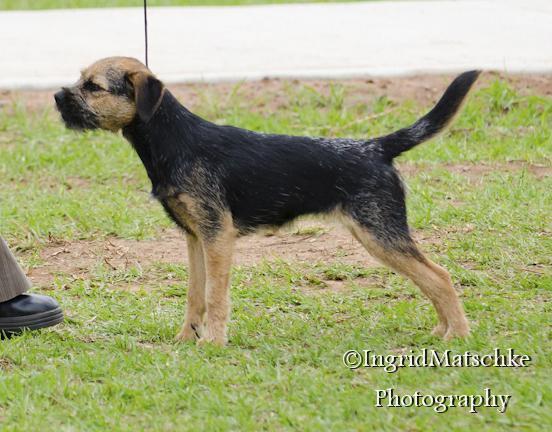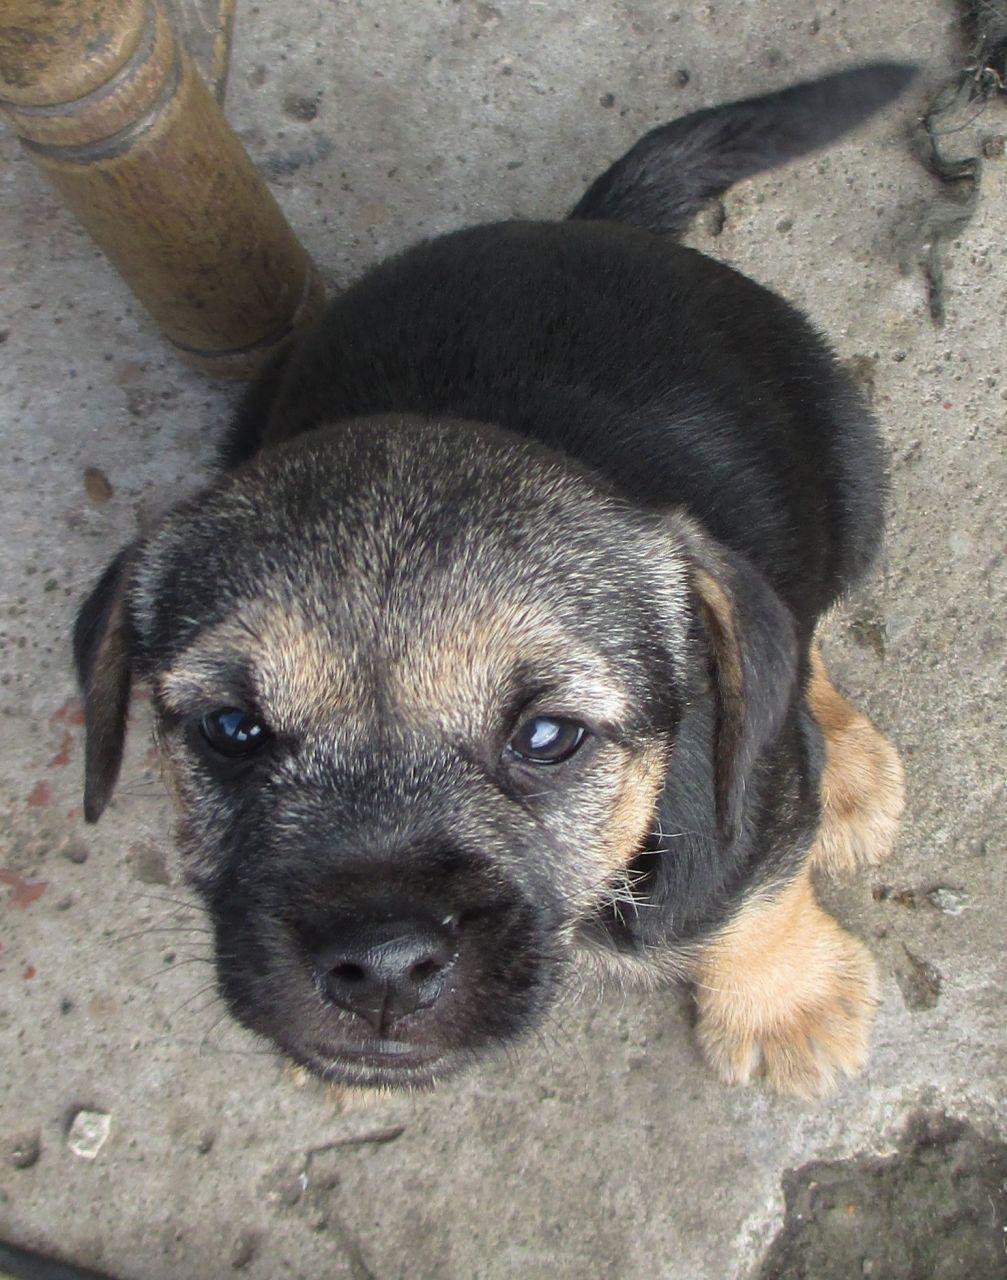The first image is the image on the left, the second image is the image on the right. For the images displayed, is the sentence "The left image shows a dog with head and body in profile and its tail extended out, and the right image shows a puppy with its tail sticking out behind it." factually correct? Answer yes or no. Yes. The first image is the image on the left, the second image is the image on the right. Examine the images to the left and right. Is the description "One dog is standing in the grass." accurate? Answer yes or no. Yes. 